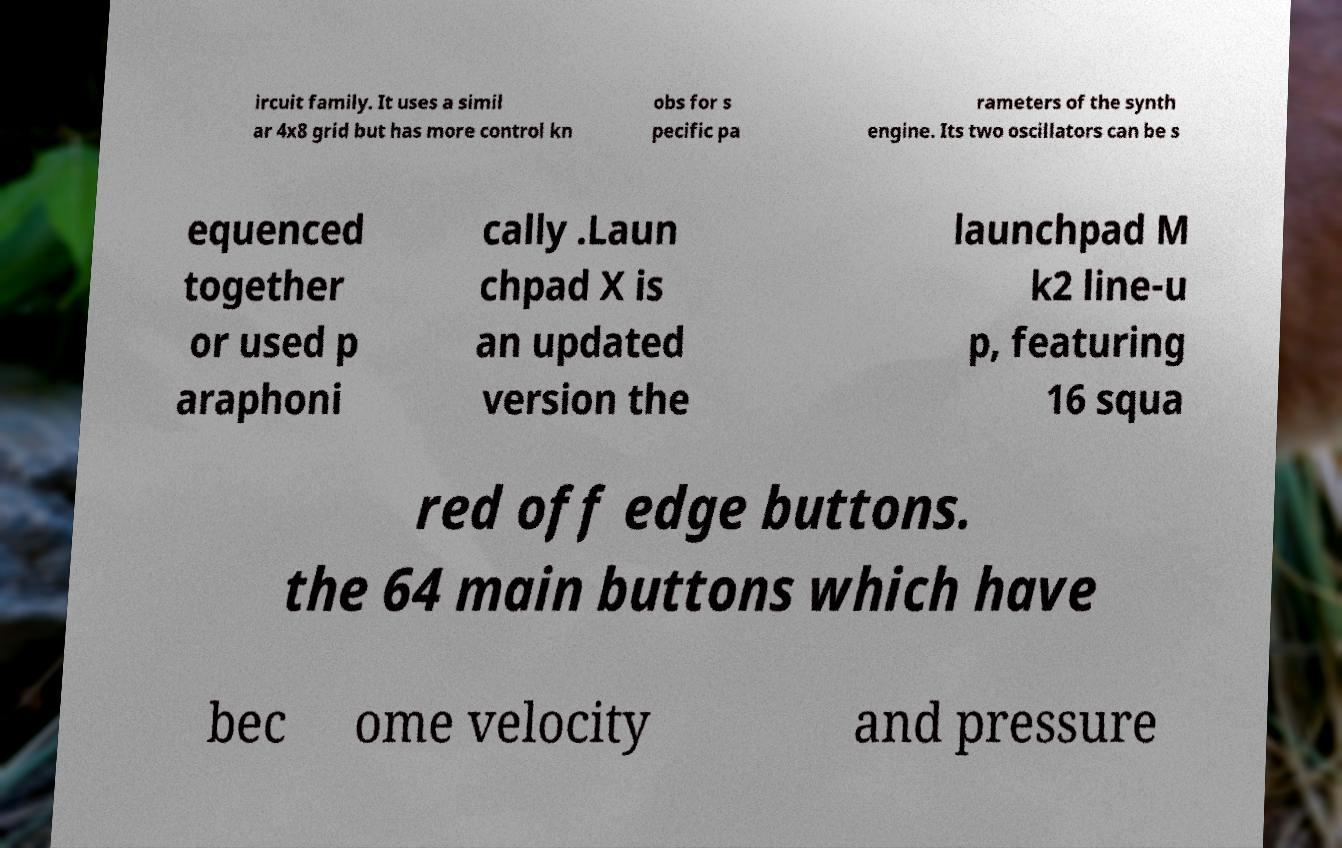Could you extract and type out the text from this image? ircuit family. It uses a simil ar 4x8 grid but has more control kn obs for s pecific pa rameters of the synth engine. Its two oscillators can be s equenced together or used p araphoni cally .Laun chpad X is an updated version the launchpad M k2 line-u p, featuring 16 squa red off edge buttons. the 64 main buttons which have bec ome velocity and pressure 